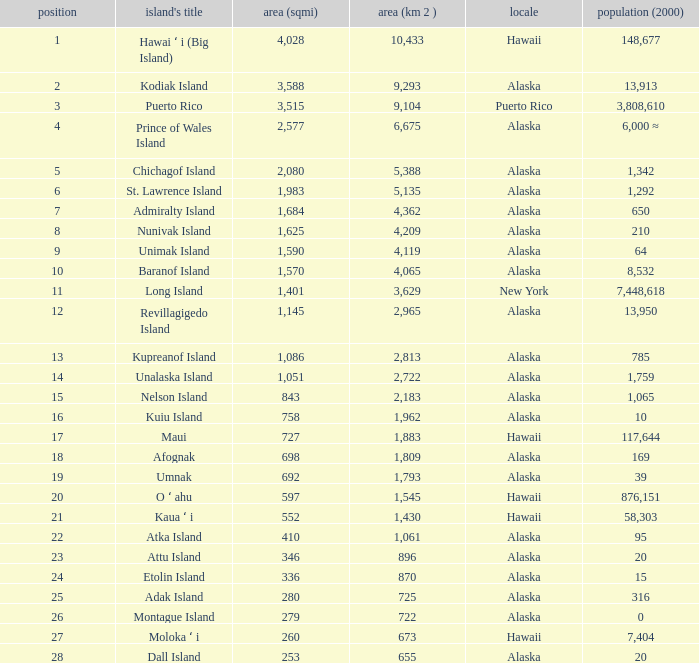What is the largest rank with 2,080 area? 5.0. 